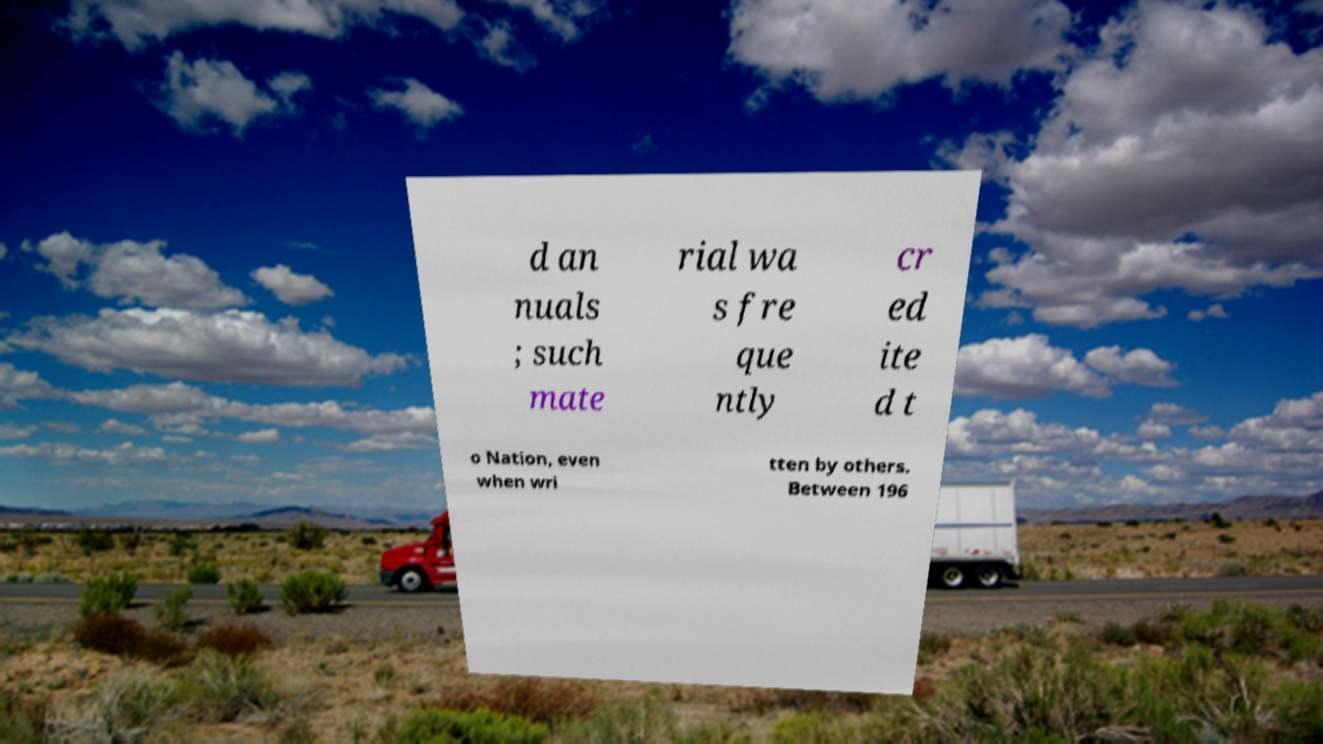Please identify and transcribe the text found in this image. d an nuals ; such mate rial wa s fre que ntly cr ed ite d t o Nation, even when wri tten by others. Between 196 